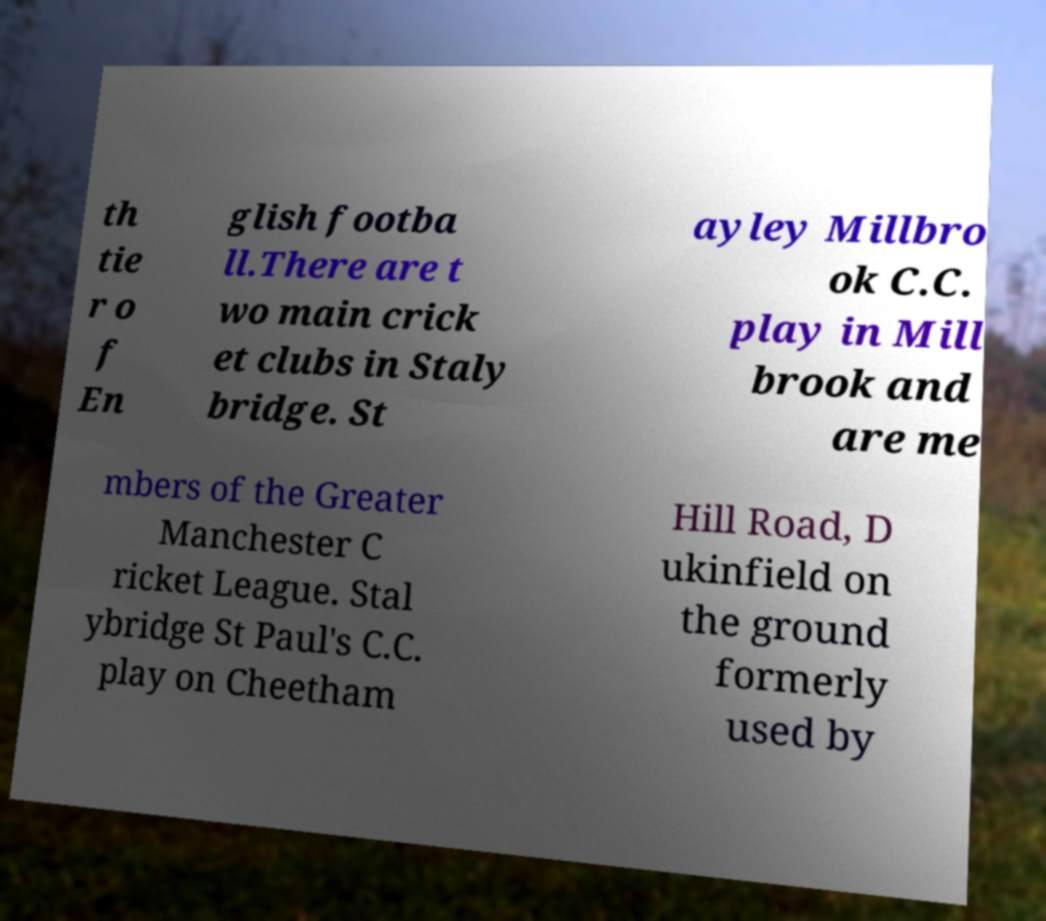Please identify and transcribe the text found in this image. th tie r o f En glish footba ll.There are t wo main crick et clubs in Staly bridge. St ayley Millbro ok C.C. play in Mill brook and are me mbers of the Greater Manchester C ricket League. Stal ybridge St Paul's C.C. play on Cheetham Hill Road, D ukinfield on the ground formerly used by 